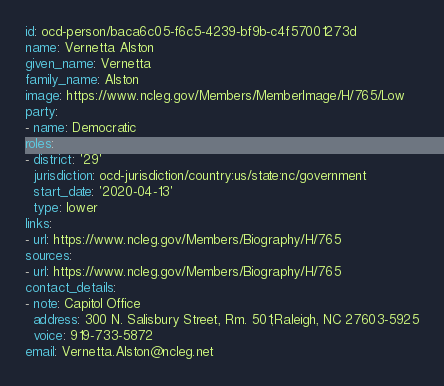<code> <loc_0><loc_0><loc_500><loc_500><_YAML_>id: ocd-person/baca6c05-f6c5-4239-bf9b-c4f57001273d
name: Vernetta Alston
given_name: Vernetta
family_name: Alston
image: https://www.ncleg.gov/Members/MemberImage/H/765/Low
party:
- name: Democratic
roles:
- district: '29'
  jurisdiction: ocd-jurisdiction/country:us/state:nc/government
  start_date: '2020-04-13'
  type: lower
links:
- url: https://www.ncleg.gov/Members/Biography/H/765
sources:
- url: https://www.ncleg.gov/Members/Biography/H/765
contact_details:
- note: Capitol Office
  address: 300 N. Salisbury Street, Rm. 501;Raleigh, NC 27603-5925
  voice: 919-733-5872
email: Vernetta.Alston@ncleg.net
</code> 